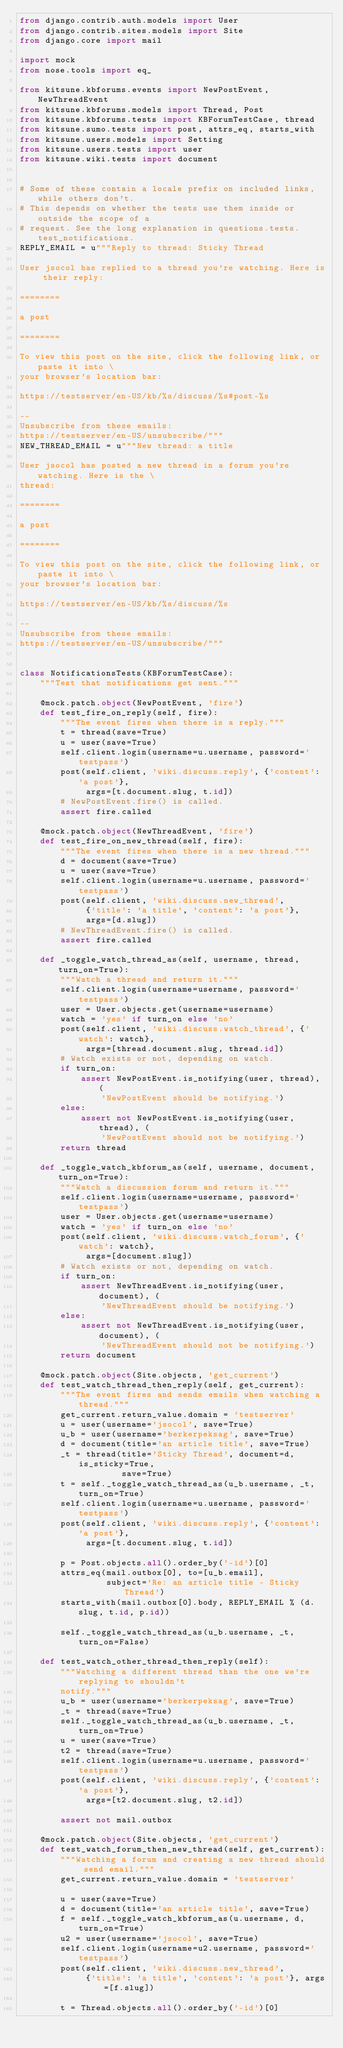<code> <loc_0><loc_0><loc_500><loc_500><_Python_>from django.contrib.auth.models import User
from django.contrib.sites.models import Site
from django.core import mail

import mock
from nose.tools import eq_

from kitsune.kbforums.events import NewPostEvent, NewThreadEvent
from kitsune.kbforums.models import Thread, Post
from kitsune.kbforums.tests import KBForumTestCase, thread
from kitsune.sumo.tests import post, attrs_eq, starts_with
from kitsune.users.models import Setting
from kitsune.users.tests import user
from kitsune.wiki.tests import document


# Some of these contain a locale prefix on included links, while others don't.
# This depends on whether the tests use them inside or outside the scope of a
# request. See the long explanation in questions.tests.test_notifications.
REPLY_EMAIL = u"""Reply to thread: Sticky Thread

User jsocol has replied to a thread you're watching. Here is their reply:

========

a post

========

To view this post on the site, click the following link, or paste it into \
your browser's location bar:

https://testserver/en-US/kb/%s/discuss/%s#post-%s

--
Unsubscribe from these emails:
https://testserver/en-US/unsubscribe/"""
NEW_THREAD_EMAIL = u"""New thread: a title

User jsocol has posted a new thread in a forum you're watching. Here is the \
thread:

========

a post

========

To view this post on the site, click the following link, or paste it into \
your browser's location bar:

https://testserver/en-US/kb/%s/discuss/%s

--
Unsubscribe from these emails:
https://testserver/en-US/unsubscribe/"""


class NotificationsTests(KBForumTestCase):
    """Test that notifications get sent."""

    @mock.patch.object(NewPostEvent, 'fire')
    def test_fire_on_reply(self, fire):
        """The event fires when there is a reply."""
        t = thread(save=True)
        u = user(save=True)
        self.client.login(username=u.username, password='testpass')
        post(self.client, 'wiki.discuss.reply', {'content': 'a post'},
             args=[t.document.slug, t.id])
        # NewPostEvent.fire() is called.
        assert fire.called

    @mock.patch.object(NewThreadEvent, 'fire')
    def test_fire_on_new_thread(self, fire):
        """The event fires when there is a new thread."""
        d = document(save=True)
        u = user(save=True)
        self.client.login(username=u.username, password='testpass')
        post(self.client, 'wiki.discuss.new_thread',
             {'title': 'a title', 'content': 'a post'},
             args=[d.slug])
        # NewThreadEvent.fire() is called.
        assert fire.called

    def _toggle_watch_thread_as(self, username, thread, turn_on=True):
        """Watch a thread and return it."""
        self.client.login(username=username, password='testpass')
        user = User.objects.get(username=username)
        watch = 'yes' if turn_on else 'no'
        post(self.client, 'wiki.discuss.watch_thread', {'watch': watch},
             args=[thread.document.slug, thread.id])
        # Watch exists or not, depending on watch.
        if turn_on:
            assert NewPostEvent.is_notifying(user, thread), (
                'NewPostEvent should be notifying.')
        else:
            assert not NewPostEvent.is_notifying(user, thread), (
                'NewPostEvent should not be notifying.')
        return thread

    def _toggle_watch_kbforum_as(self, username, document, turn_on=True):
        """Watch a discussion forum and return it."""
        self.client.login(username=username, password='testpass')
        user = User.objects.get(username=username)
        watch = 'yes' if turn_on else 'no'
        post(self.client, 'wiki.discuss.watch_forum', {'watch': watch},
             args=[document.slug])
        # Watch exists or not, depending on watch.
        if turn_on:
            assert NewThreadEvent.is_notifying(user, document), (
                'NewThreadEvent should be notifying.')
        else:
            assert not NewThreadEvent.is_notifying(user, document), (
                'NewThreadEvent should not be notifying.')
        return document

    @mock.patch.object(Site.objects, 'get_current')
    def test_watch_thread_then_reply(self, get_current):
        """The event fires and sends emails when watching a thread."""
        get_current.return_value.domain = 'testserver'
        u = user(username='jsocol', save=True)
        u_b = user(username='berkerpeksag', save=True)
        d = document(title='an article title', save=True)
        _t = thread(title='Sticky Thread', document=d, is_sticky=True,
                    save=True)
        t = self._toggle_watch_thread_as(u_b.username, _t, turn_on=True)
        self.client.login(username=u.username, password='testpass')
        post(self.client, 'wiki.discuss.reply', {'content': 'a post'},
             args=[t.document.slug, t.id])

        p = Post.objects.all().order_by('-id')[0]
        attrs_eq(mail.outbox[0], to=[u_b.email],
                 subject='Re: an article title - Sticky Thread')
        starts_with(mail.outbox[0].body, REPLY_EMAIL % (d.slug, t.id, p.id))

        self._toggle_watch_thread_as(u_b.username, _t, turn_on=False)

    def test_watch_other_thread_then_reply(self):
        """Watching a different thread than the one we're replying to shouldn't
        notify."""
        u_b = user(username='berkerpeksag', save=True)
        _t = thread(save=True)
        self._toggle_watch_thread_as(u_b.username, _t, turn_on=True)
        u = user(save=True)
        t2 = thread(save=True)
        self.client.login(username=u.username, password='testpass')
        post(self.client, 'wiki.discuss.reply', {'content': 'a post'},
             args=[t2.document.slug, t2.id])

        assert not mail.outbox

    @mock.patch.object(Site.objects, 'get_current')
    def test_watch_forum_then_new_thread(self, get_current):
        """Watching a forum and creating a new thread should send email."""
        get_current.return_value.domain = 'testserver'

        u = user(save=True)
        d = document(title='an article title', save=True)
        f = self._toggle_watch_kbforum_as(u.username, d, turn_on=True)
        u2 = user(username='jsocol', save=True)
        self.client.login(username=u2.username, password='testpass')
        post(self.client, 'wiki.discuss.new_thread',
             {'title': 'a title', 'content': 'a post'}, args=[f.slug])

        t = Thread.objects.all().order_by('-id')[0]</code> 